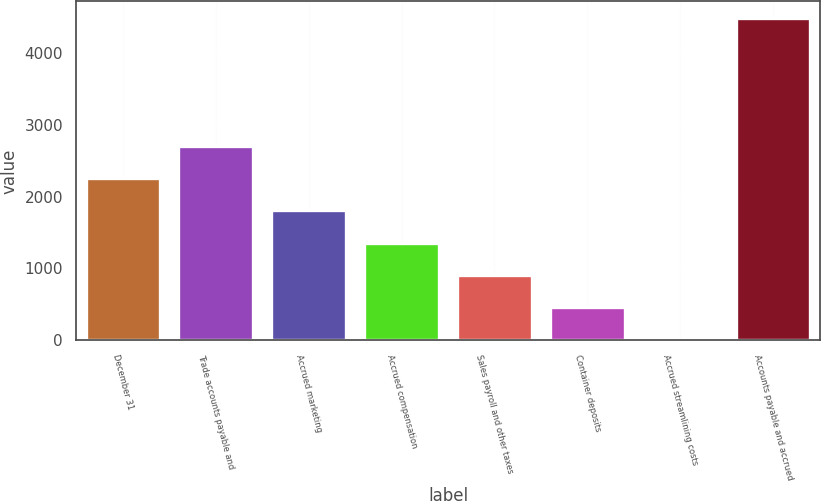<chart> <loc_0><loc_0><loc_500><loc_500><bar_chart><fcel>December 31<fcel>Trade accounts payable and<fcel>Accrued marketing<fcel>Accrued compensation<fcel>Sales payroll and other taxes<fcel>Container deposits<fcel>Accrued streamlining costs<fcel>Accounts payable and accrued<nl><fcel>2255.5<fcel>2703<fcel>1808<fcel>1360.5<fcel>913<fcel>465.5<fcel>18<fcel>4493<nl></chart> 